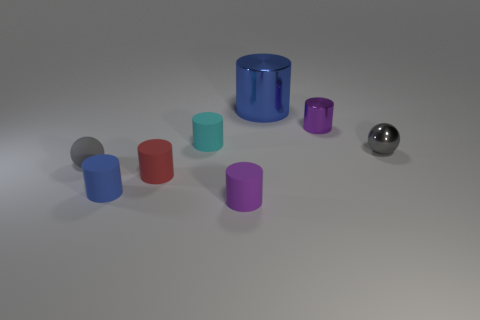Subtract all red matte cylinders. How many cylinders are left? 5 Subtract all purple cylinders. How many cylinders are left? 4 Subtract 2 cylinders. How many cylinders are left? 4 Subtract all brown cylinders. Subtract all red spheres. How many cylinders are left? 6 Add 1 gray metal objects. How many objects exist? 9 Subtract all spheres. How many objects are left? 6 Add 2 large cylinders. How many large cylinders are left? 3 Add 2 metal cubes. How many metal cubes exist? 2 Subtract 1 blue cylinders. How many objects are left? 7 Subtract all big blue things. Subtract all tiny purple metallic objects. How many objects are left? 6 